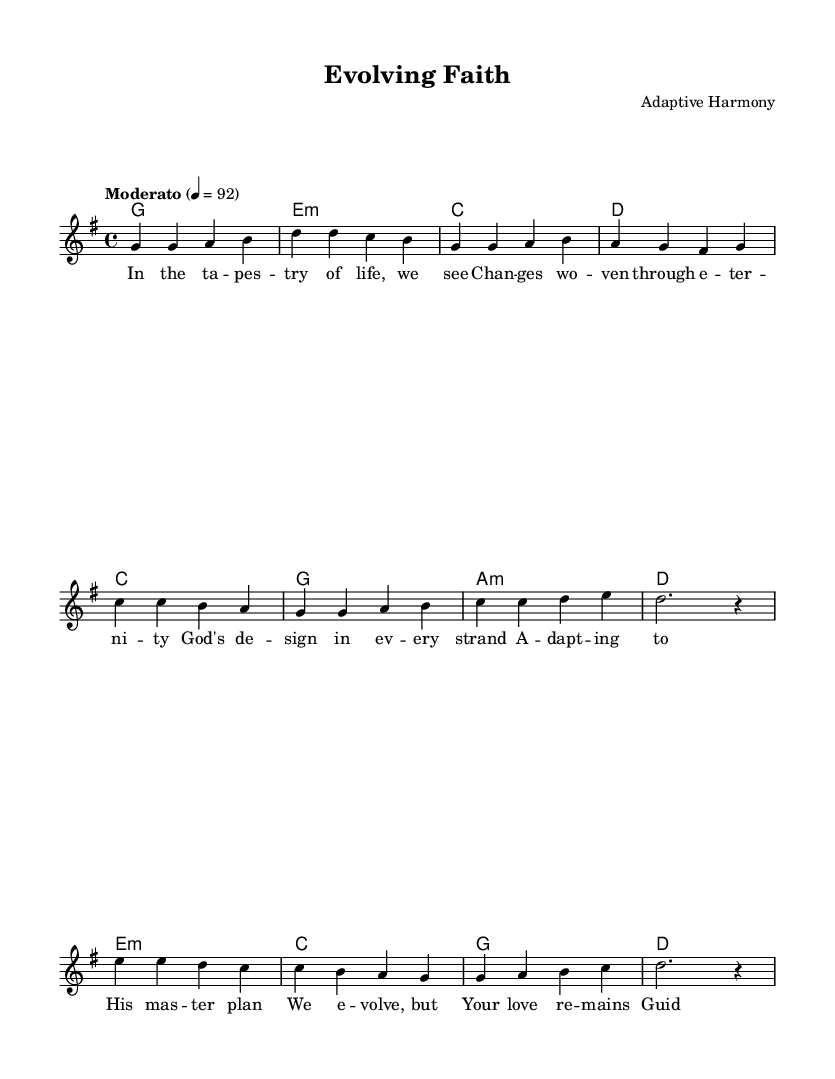What is the key signature of this music? The key signature is G major, which has one sharp (F#). This can be identified by looking for the sharp sign at the beginning of the staff after the clef.
Answer: G major What is the time signature of this music? The time signature is 4/4, indicated at the beginning of the score. This means there are four beats in each measure and the quarter note gets one beat.
Answer: 4/4 What is the tempo marking for this piece? The tempo marking is "Moderato," which suggests a moderate pace. This is indicated above the staff at the beginning of the score, accompanied by the beats per minute marker of 92.
Answer: Moderato How many verses are in the structure of this song? The song structure shows one verse, as indicated by the lyrics labeled as "verseOne" in the score. There are no repeated verses labeled, suggesting it's a single verse.
Answer: One What is the predominant theme reflected in the lyrics? The predominant theme in the lyrics revolves around adaptation and divine guidance through change. This can be deduced from phrases discussing evolution and God's plan, as detailed in both the verses and chorus.
Answer: Adaptation In which section does the bridge appear in relation to the verses and chorus? The bridge appears after the chorus, which can be determined by the lyrics being denoted separately as "bridge" following the "chorus." This indicates a typical structure where the bridge provides contrast after the main thematic sections.
Answer: After the chorus 